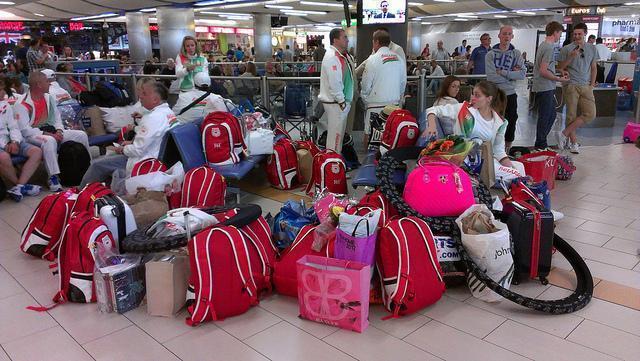Where is this scene taking place?
From the following set of four choices, select the accurate answer to respond to the question.
Options: Airport, mall, dmv, school. Airport. 